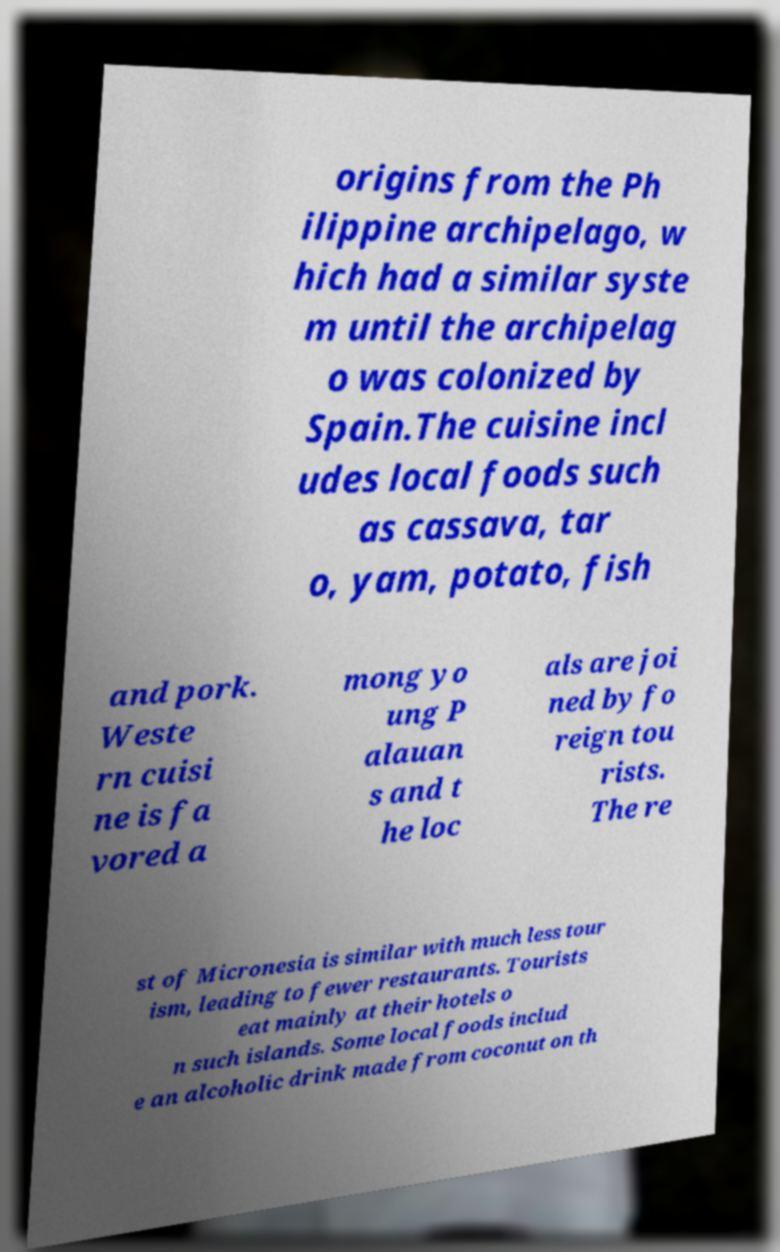Can you accurately transcribe the text from the provided image for me? origins from the Ph ilippine archipelago, w hich had a similar syste m until the archipelag o was colonized by Spain.The cuisine incl udes local foods such as cassava, tar o, yam, potato, fish and pork. Weste rn cuisi ne is fa vored a mong yo ung P alauan s and t he loc als are joi ned by fo reign tou rists. The re st of Micronesia is similar with much less tour ism, leading to fewer restaurants. Tourists eat mainly at their hotels o n such islands. Some local foods includ e an alcoholic drink made from coconut on th 